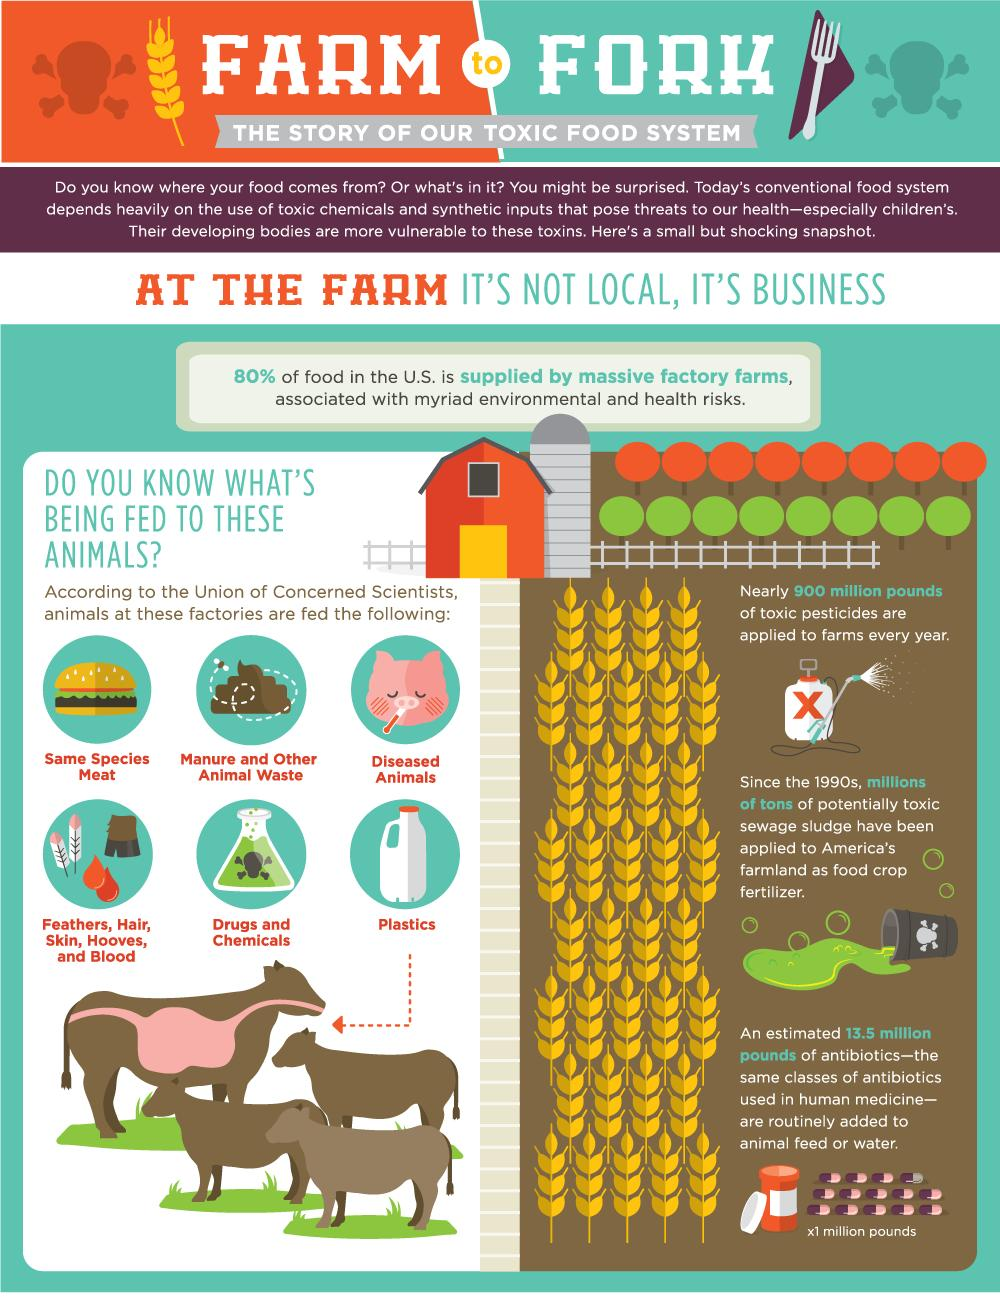Point out several critical features in this image. There are six types of high-risk feed provided to farm animals. 